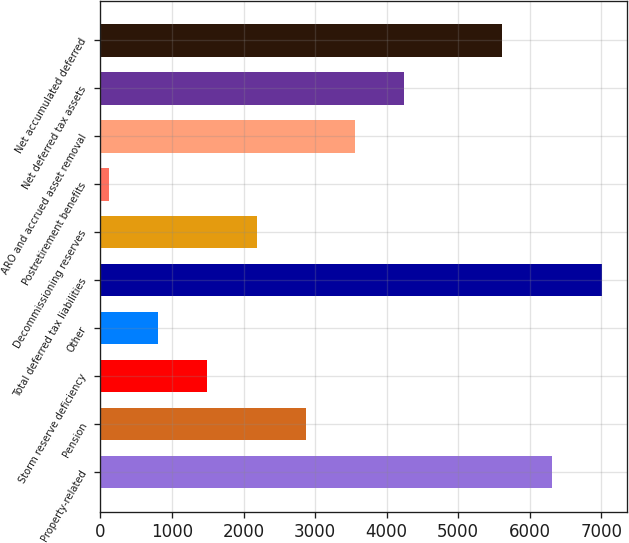Convert chart to OTSL. <chart><loc_0><loc_0><loc_500><loc_500><bar_chart><fcel>Property-related<fcel>Pension<fcel>Storm reserve deficiency<fcel>Other<fcel>Total deferred tax liabilities<fcel>Decommissioning reserves<fcel>Postretirement benefits<fcel>ARO and accrued asset removal<fcel>Net deferred tax assets<fcel>Net accumulated deferred<nl><fcel>6306.1<fcel>2870.4<fcel>1492.2<fcel>803.1<fcel>7005<fcel>2181.3<fcel>114<fcel>3559.5<fcel>4248.6<fcel>5617<nl></chart> 